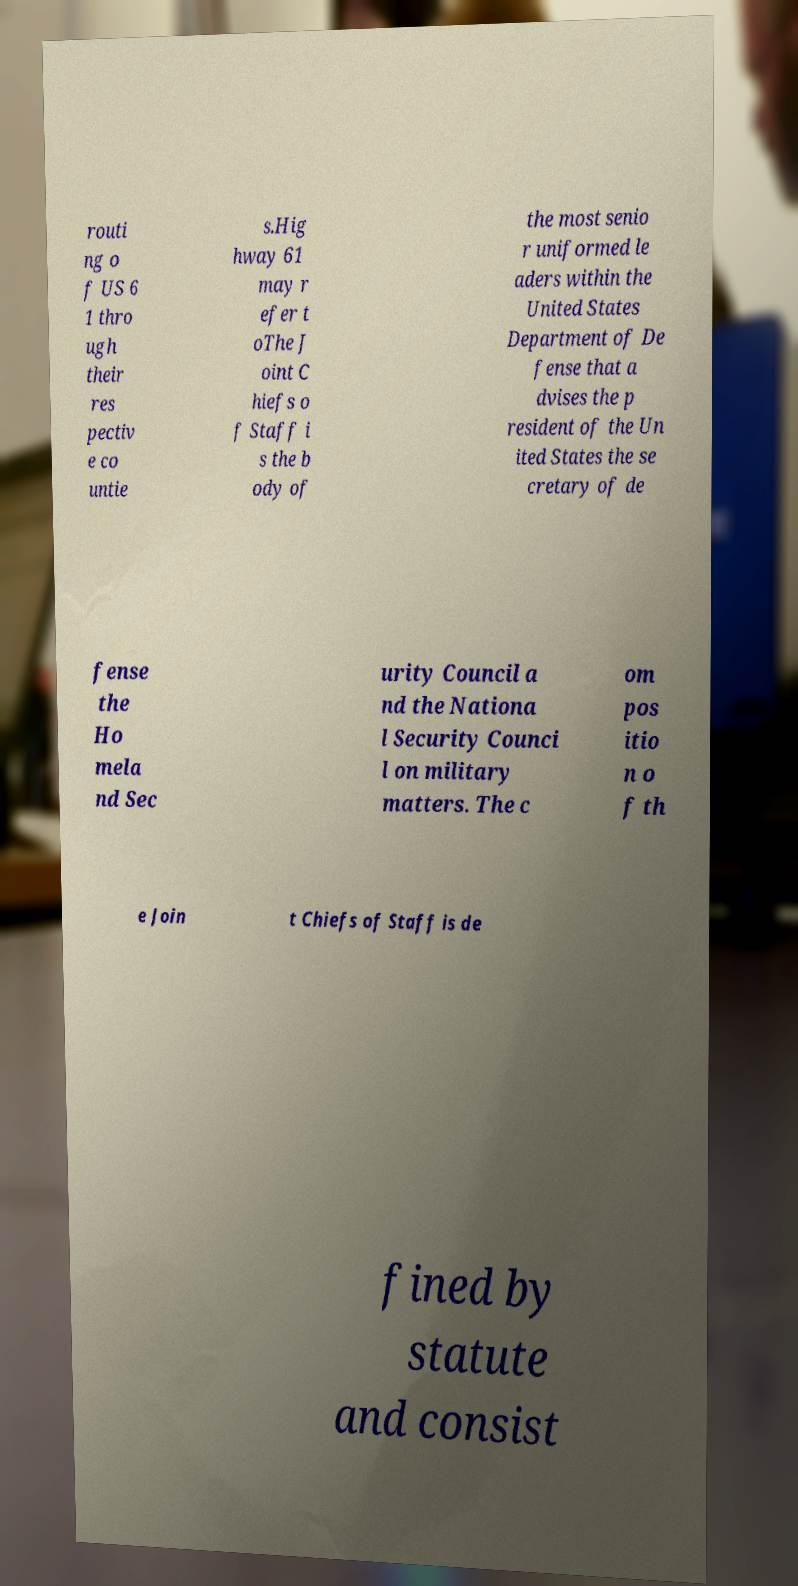I need the written content from this picture converted into text. Can you do that? routi ng o f US 6 1 thro ugh their res pectiv e co untie s.Hig hway 61 may r efer t oThe J oint C hiefs o f Staff i s the b ody of the most senio r uniformed le aders within the United States Department of De fense that a dvises the p resident of the Un ited States the se cretary of de fense the Ho mela nd Sec urity Council a nd the Nationa l Security Counci l on military matters. The c om pos itio n o f th e Join t Chiefs of Staff is de fined by statute and consist 